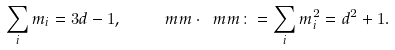Convert formula to latex. <formula><loc_0><loc_0><loc_500><loc_500>\label l { e q \colon e e } \sum _ { i } m _ { i } = 3 d - 1 , \quad \ m m \cdot \ m m \colon = \sum _ { i } m _ { i } ^ { 2 } = d ^ { 2 } + 1 .</formula> 